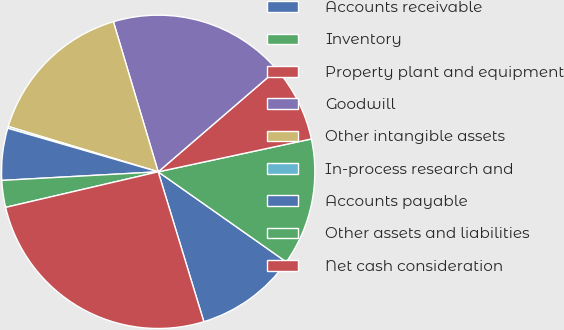Convert chart. <chart><loc_0><loc_0><loc_500><loc_500><pie_chart><fcel>Accounts receivable<fcel>Inventory<fcel>Property plant and equipment<fcel>Goodwill<fcel>Other intangible assets<fcel>In-process research and<fcel>Accounts payable<fcel>Other assets and liabilities<fcel>Net cash consideration<nl><fcel>10.54%<fcel>13.12%<fcel>7.95%<fcel>18.3%<fcel>15.71%<fcel>0.19%<fcel>5.36%<fcel>2.77%<fcel>26.06%<nl></chart> 